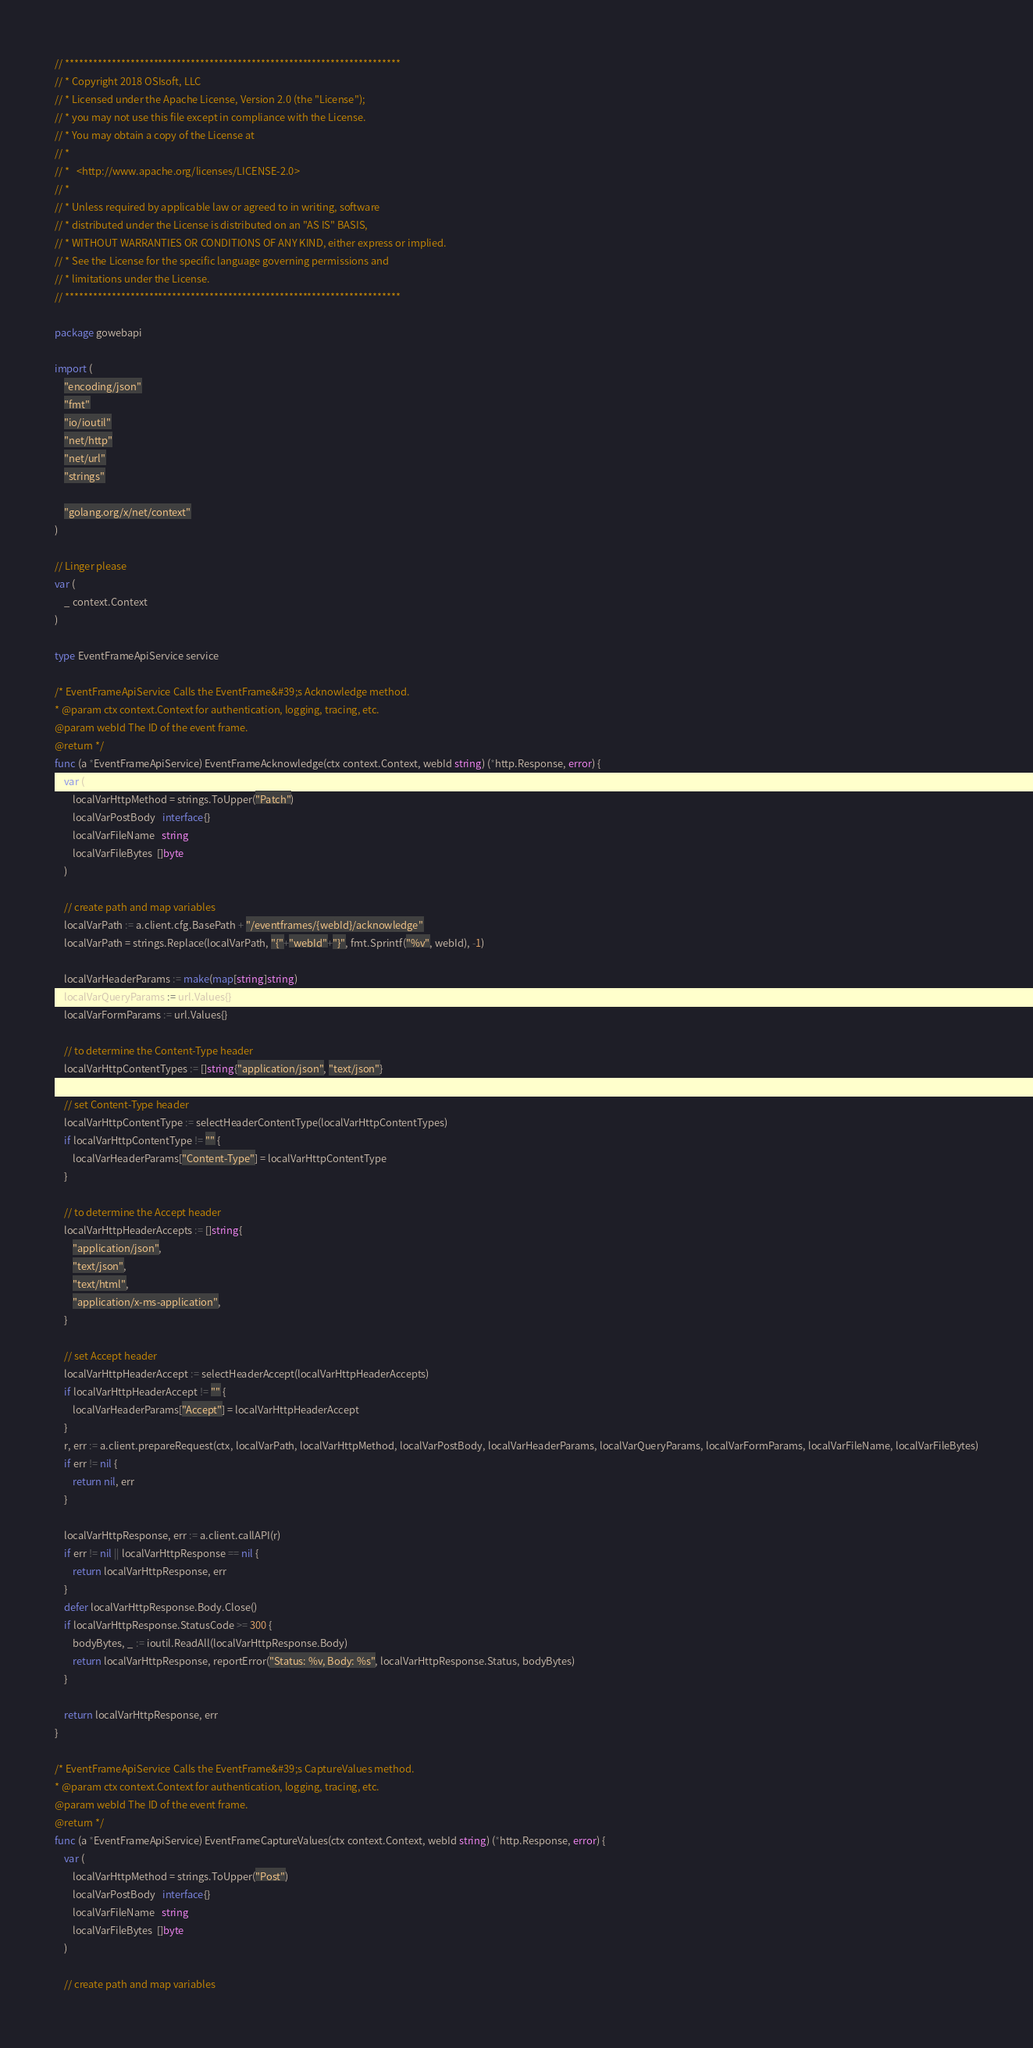<code> <loc_0><loc_0><loc_500><loc_500><_Go_>// ************************************************************************
// * Copyright 2018 OSIsoft, LLC
// * Licensed under the Apache License, Version 2.0 (the "License");
// * you may not use this file except in compliance with the License.
// * You may obtain a copy of the License at
// * 
// *   <http://www.apache.org/licenses/LICENSE-2.0>
// * 
// * Unless required by applicable law or agreed to in writing, software
// * distributed under the License is distributed on an "AS IS" BASIS,
// * WITHOUT WARRANTIES OR CONDITIONS OF ANY KIND, either express or implied.
// * See the License for the specific language governing permissions and
// * limitations under the License.
// ************************************************************************

package gowebapi

import (
	"encoding/json"
	"fmt"
	"io/ioutil"
	"net/http"
	"net/url"
	"strings"

	"golang.org/x/net/context"
)

// Linger please
var (
	_ context.Context
)

type EventFrameApiService service

/* EventFrameApiService Calls the EventFrame&#39;s Acknowledge method.
* @param ctx context.Context for authentication, logging, tracing, etc.
@param webId The ID of the event frame.
@return */
func (a *EventFrameApiService) EventFrameAcknowledge(ctx context.Context, webId string) (*http.Response, error) {
	var (
		localVarHttpMethod = strings.ToUpper("Patch")
		localVarPostBody   interface{}
		localVarFileName   string
		localVarFileBytes  []byte
	)

	// create path and map variables
	localVarPath := a.client.cfg.BasePath + "/eventframes/{webId}/acknowledge"
	localVarPath = strings.Replace(localVarPath, "{"+"webId"+"}", fmt.Sprintf("%v", webId), -1)

	localVarHeaderParams := make(map[string]string)
	localVarQueryParams := url.Values{}
	localVarFormParams := url.Values{}

	// to determine the Content-Type header
	localVarHttpContentTypes := []string{"application/json", "text/json"}

	// set Content-Type header
	localVarHttpContentType := selectHeaderContentType(localVarHttpContentTypes)
	if localVarHttpContentType != "" {
		localVarHeaderParams["Content-Type"] = localVarHttpContentType
	}

	// to determine the Accept header
	localVarHttpHeaderAccepts := []string{
		"application/json",
		"text/json",
		"text/html",
		"application/x-ms-application",
	}

	// set Accept header
	localVarHttpHeaderAccept := selectHeaderAccept(localVarHttpHeaderAccepts)
	if localVarHttpHeaderAccept != "" {
		localVarHeaderParams["Accept"] = localVarHttpHeaderAccept
	}
	r, err := a.client.prepareRequest(ctx, localVarPath, localVarHttpMethod, localVarPostBody, localVarHeaderParams, localVarQueryParams, localVarFormParams, localVarFileName, localVarFileBytes)
	if err != nil {
		return nil, err
	}

	localVarHttpResponse, err := a.client.callAPI(r)
	if err != nil || localVarHttpResponse == nil {
		return localVarHttpResponse, err
	}
	defer localVarHttpResponse.Body.Close()
	if localVarHttpResponse.StatusCode >= 300 {
		bodyBytes, _ := ioutil.ReadAll(localVarHttpResponse.Body)
		return localVarHttpResponse, reportError("Status: %v, Body: %s", localVarHttpResponse.Status, bodyBytes)
	}

	return localVarHttpResponse, err
}

/* EventFrameApiService Calls the EventFrame&#39;s CaptureValues method.
* @param ctx context.Context for authentication, logging, tracing, etc.
@param webId The ID of the event frame.
@return */
func (a *EventFrameApiService) EventFrameCaptureValues(ctx context.Context, webId string) (*http.Response, error) {
	var (
		localVarHttpMethod = strings.ToUpper("Post")
		localVarPostBody   interface{}
		localVarFileName   string
		localVarFileBytes  []byte
	)

	// create path and map variables</code> 